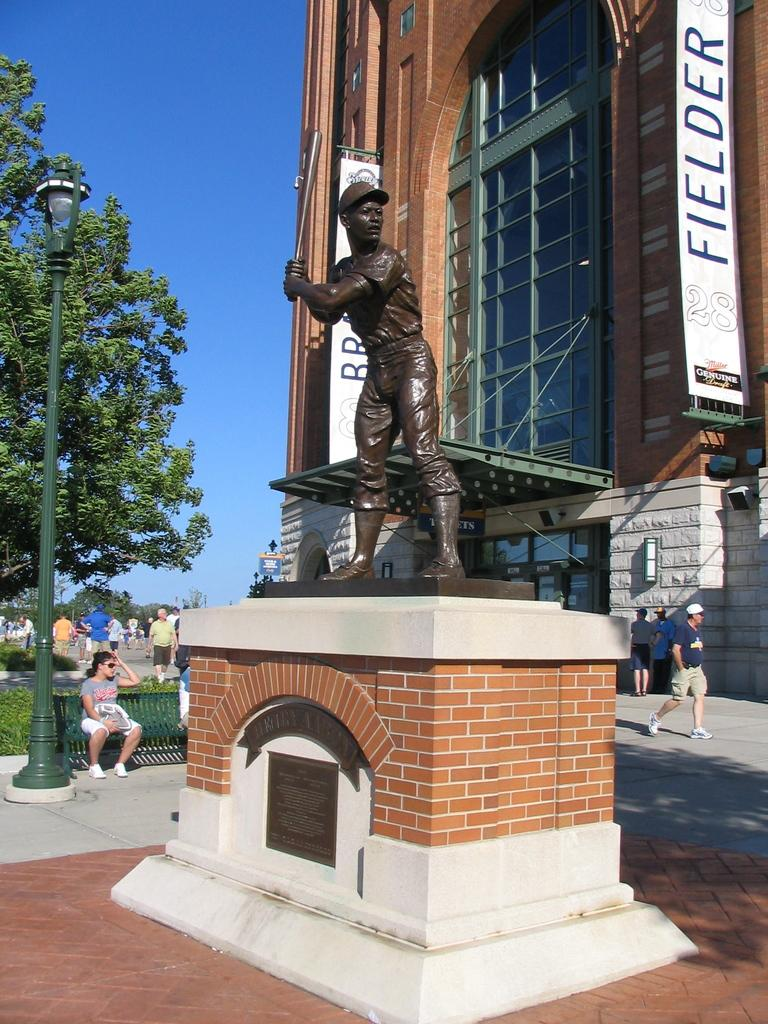<image>
Describe the image concisely. A banner that says Fielder hangs outside of a building near a statue. 